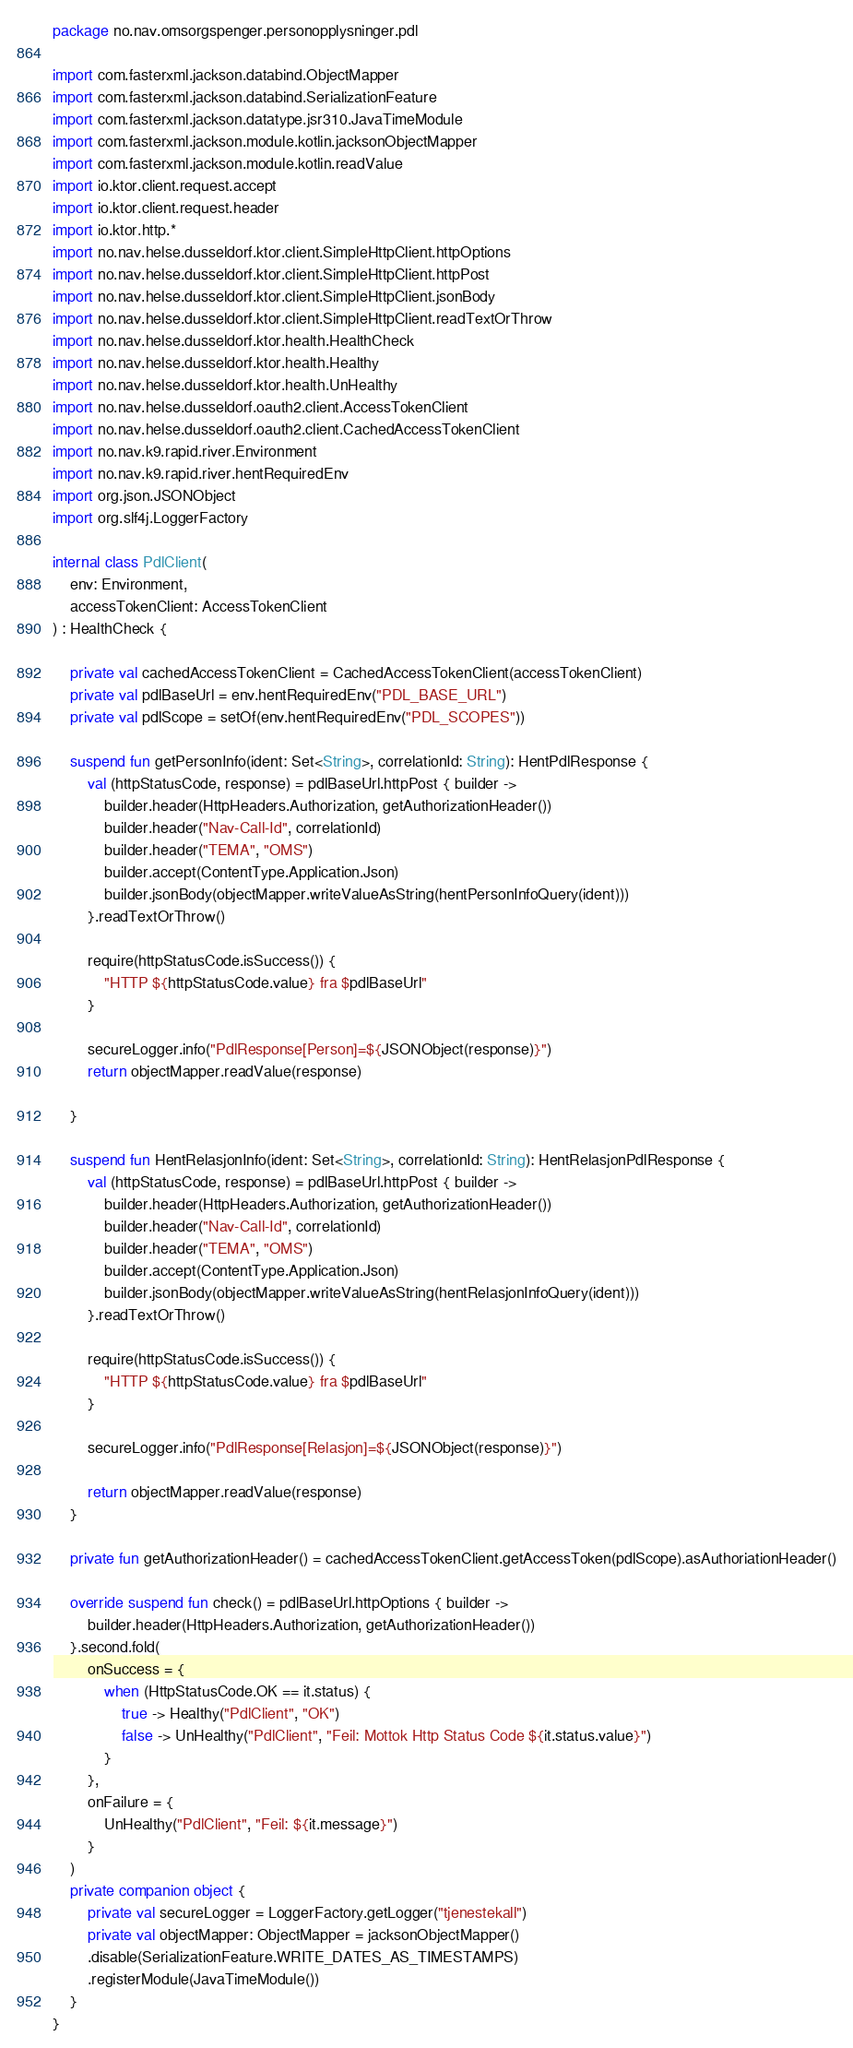<code> <loc_0><loc_0><loc_500><loc_500><_Kotlin_>package no.nav.omsorgspenger.personopplysninger.pdl

import com.fasterxml.jackson.databind.ObjectMapper
import com.fasterxml.jackson.databind.SerializationFeature
import com.fasterxml.jackson.datatype.jsr310.JavaTimeModule
import com.fasterxml.jackson.module.kotlin.jacksonObjectMapper
import com.fasterxml.jackson.module.kotlin.readValue
import io.ktor.client.request.accept
import io.ktor.client.request.header
import io.ktor.http.*
import no.nav.helse.dusseldorf.ktor.client.SimpleHttpClient.httpOptions
import no.nav.helse.dusseldorf.ktor.client.SimpleHttpClient.httpPost
import no.nav.helse.dusseldorf.ktor.client.SimpleHttpClient.jsonBody
import no.nav.helse.dusseldorf.ktor.client.SimpleHttpClient.readTextOrThrow
import no.nav.helse.dusseldorf.ktor.health.HealthCheck
import no.nav.helse.dusseldorf.ktor.health.Healthy
import no.nav.helse.dusseldorf.ktor.health.UnHealthy
import no.nav.helse.dusseldorf.oauth2.client.AccessTokenClient
import no.nav.helse.dusseldorf.oauth2.client.CachedAccessTokenClient
import no.nav.k9.rapid.river.Environment
import no.nav.k9.rapid.river.hentRequiredEnv
import org.json.JSONObject
import org.slf4j.LoggerFactory

internal class PdlClient(
    env: Environment,
    accessTokenClient: AccessTokenClient
) : HealthCheck {

    private val cachedAccessTokenClient = CachedAccessTokenClient(accessTokenClient)
    private val pdlBaseUrl = env.hentRequiredEnv("PDL_BASE_URL")
    private val pdlScope = setOf(env.hentRequiredEnv("PDL_SCOPES"))

    suspend fun getPersonInfo(ident: Set<String>, correlationId: String): HentPdlResponse {
        val (httpStatusCode, response) = pdlBaseUrl.httpPost { builder ->
            builder.header(HttpHeaders.Authorization, getAuthorizationHeader())
            builder.header("Nav-Call-Id", correlationId)
            builder.header("TEMA", "OMS")
            builder.accept(ContentType.Application.Json)
            builder.jsonBody(objectMapper.writeValueAsString(hentPersonInfoQuery(ident)))
        }.readTextOrThrow()

        require(httpStatusCode.isSuccess()) {
            "HTTP ${httpStatusCode.value} fra $pdlBaseUrl"
        }

        secureLogger.info("PdlResponse[Person]=${JSONObject(response)}")
        return objectMapper.readValue(response)

    }

    suspend fun HentRelasjonInfo(ident: Set<String>, correlationId: String): HentRelasjonPdlResponse {
        val (httpStatusCode, response) = pdlBaseUrl.httpPost { builder ->
            builder.header(HttpHeaders.Authorization, getAuthorizationHeader())
            builder.header("Nav-Call-Id", correlationId)
            builder.header("TEMA", "OMS")
            builder.accept(ContentType.Application.Json)
            builder.jsonBody(objectMapper.writeValueAsString(hentRelasjonInfoQuery(ident)))
        }.readTextOrThrow()

        require(httpStatusCode.isSuccess()) {
            "HTTP ${httpStatusCode.value} fra $pdlBaseUrl"
        }

        secureLogger.info("PdlResponse[Relasjon]=${JSONObject(response)}")

        return objectMapper.readValue(response)
    }

    private fun getAuthorizationHeader() = cachedAccessTokenClient.getAccessToken(pdlScope).asAuthoriationHeader()

    override suspend fun check() = pdlBaseUrl.httpOptions { builder ->
        builder.header(HttpHeaders.Authorization, getAuthorizationHeader())
    }.second.fold(
        onSuccess = {
            when (HttpStatusCode.OK == it.status) {
                true -> Healthy("PdlClient", "OK")
                false -> UnHealthy("PdlClient", "Feil: Mottok Http Status Code ${it.status.value}")
            }
        },
        onFailure = {
            UnHealthy("PdlClient", "Feil: ${it.message}")
        }
    )
    private companion object {
        private val secureLogger = LoggerFactory.getLogger("tjenestekall")
        private val objectMapper: ObjectMapper = jacksonObjectMapper()
        .disable(SerializationFeature.WRITE_DATES_AS_TIMESTAMPS)
        .registerModule(JavaTimeModule())
    }
}
</code> 